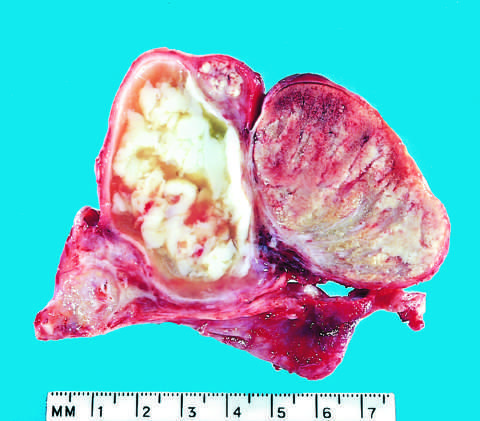what is seen on the right?
Answer the question using a single word or phrase. Normal testis 